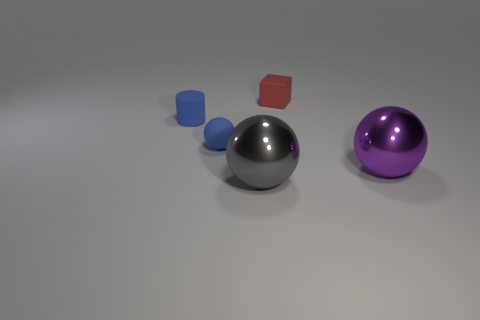Add 2 big brown metal cubes. How many objects exist? 7 Subtract all balls. How many objects are left? 2 Subtract all large purple metallic objects. Subtract all tiny red rubber things. How many objects are left? 3 Add 1 blocks. How many blocks are left? 2 Add 5 balls. How many balls exist? 8 Subtract 0 cyan blocks. How many objects are left? 5 